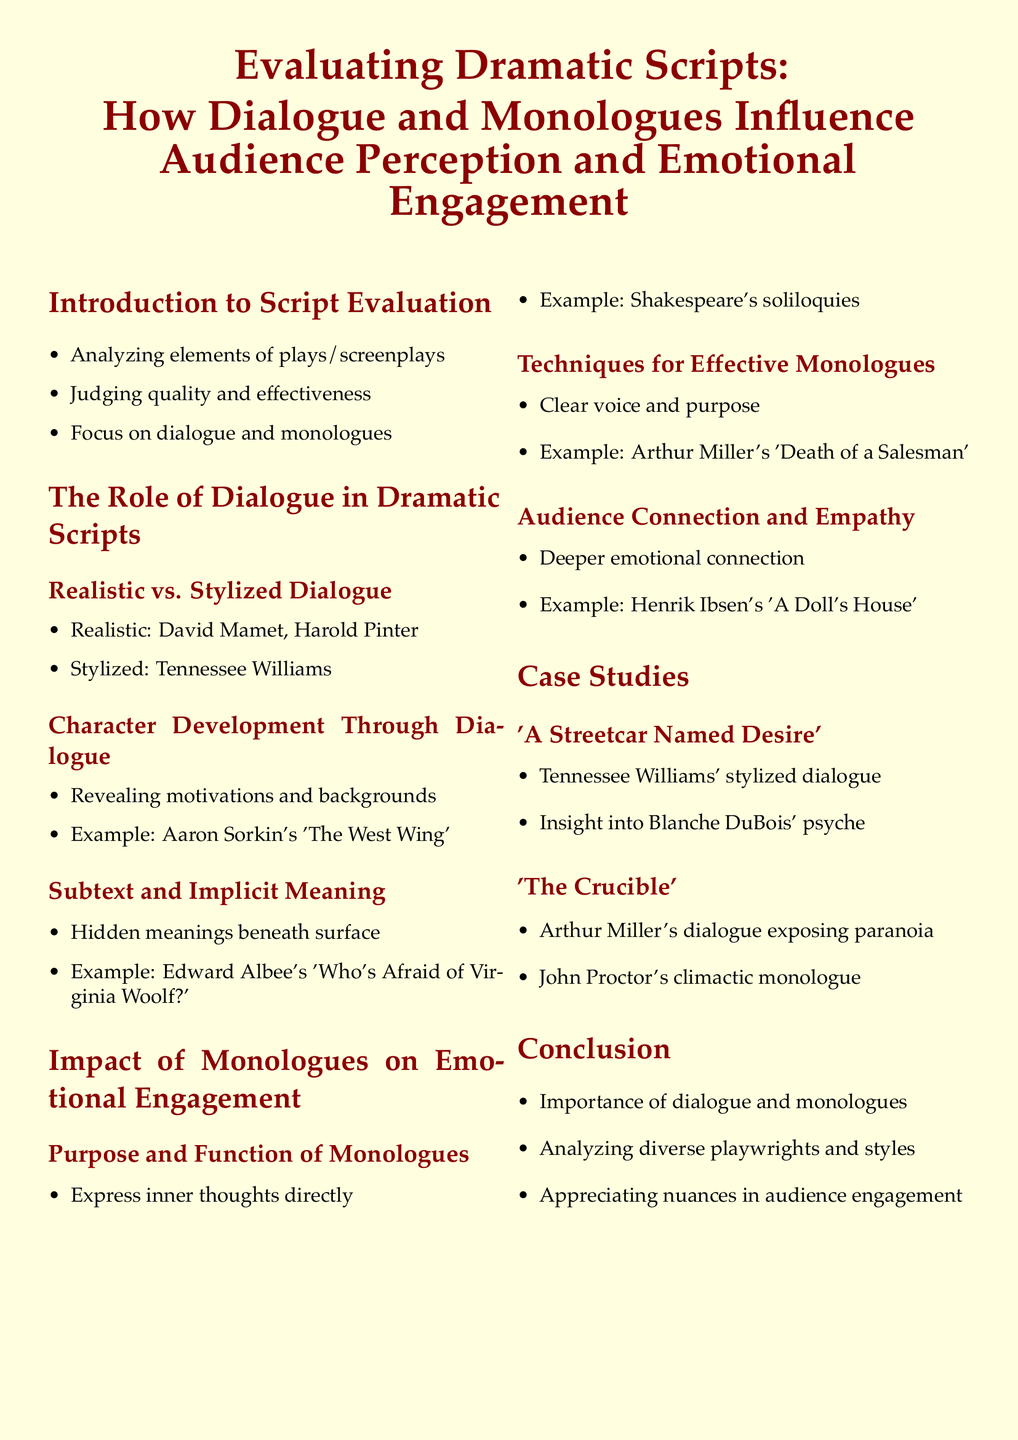What is the primary focus of the document? The document focuses on evaluating dramatic scripts, specifically how dialogue and monologues influence audience perception and emotional engagement.
Answer: Evaluating dramatic scripts Who is mentioned as an example of a playwright known for realistic dialogue? The document cites David Mamet as an example of a playwright known for realistic dialogue.
Answer: David Mamet What play is referenced in relation to character development through dialogue? Aaron Sorkin's 'The West Wing' is referenced as an example of character development through dialogue.
Answer: The West Wing What type of dialogue does Tennessee Williams exemplify? The document identifies Tennessee Williams as an example of stylized dialogue.
Answer: Stylized dialogue Which soliloquies are mentioned as a technique for effective monologues? Shakespeare's soliloquies are mentioned in relation to the purpose and function of monologues.
Answer: Shakespeare's soliloquies What emotional connection technique is associated with Henrik Ibsen's work? The document notes that Ibsen's 'A Doll's House' promotes deeper emotional connection and empathy.
Answer: Deeper emotional connection What is the significance of John Proctor's monologue in 'The Crucible'? John Proctor's climactic monologue is noted for exposing paranoia in the play.
Answer: Exposing paranoia What does the conclusion emphasize about dialogue and monologues? The conclusion emphasizes the importance of dialogue and monologues in analyzing diverse playwrights and styles.
Answer: Importance of dialogue and monologues In which section can you find case studies? Case studies are found in a dedicated section labeled 'Case Studies'.
Answer: Case Studies 